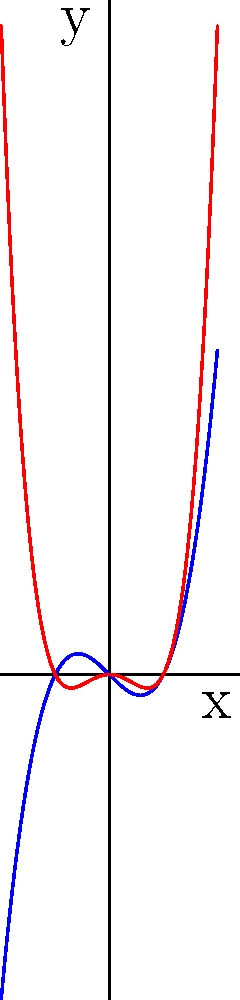Consider the two polynomial functions graphed above: a blue curve representing an odd degree polynomial and a red curve representing an even degree polynomial. How do these graphs demonstrate the symmetry properties of odd and even degree polynomials? Explain the key differences in their behavior around the y-axis. To answer this question, let's analyze the symmetry properties of odd and even degree polynomials:

1. Odd degree polynomials:
   - The blue curve represents an odd degree polynomial (likely a cubic function).
   - It shows rotational symmetry about the origin (0,0).
   - This means if we rotate the graph 180° around the origin, it will look the same.
   - Mathematically, for an odd function $f(-x) = -f(x)$.

2. Even degree polynomials:
   - The red curve represents an even degree polynomial (likely a quartic function).
   - It demonstrates reflection symmetry about the y-axis.
   - If we fold the graph along the y-axis, the two halves will perfectly overlap.
   - Mathematically, for an even function $f(-x) = f(x)$.

3. Key differences:
   - The odd degree polynomial (blue) passes through the origin, while the even degree polynomial (red) does not necessarily do so.
   - The odd degree polynomial has opposite y-values for opposite x-values, creating a "point symmetry" effect.
   - The even degree polynomial has identical y-values for opposite x-values, creating a "mirror image" effect across the y-axis.

4. Behavior around the y-axis:
   - The odd degree polynomial crosses the y-axis at a single point (the origin).
   - The even degree polynomial may touch or cross the y-axis at one or more points, but always symmetrically.

These symmetry properties are fundamental characteristics that distinguish odd and even degree polynomials, which is crucial for analyzing and predicting their behavior in various mathematical and real-world applications.
Answer: Odd degree polynomials show rotational symmetry about the origin ($f(-x) = -f(x)$), while even degree polynomials show reflection symmetry about the y-axis ($f(-x) = f(x)$). 